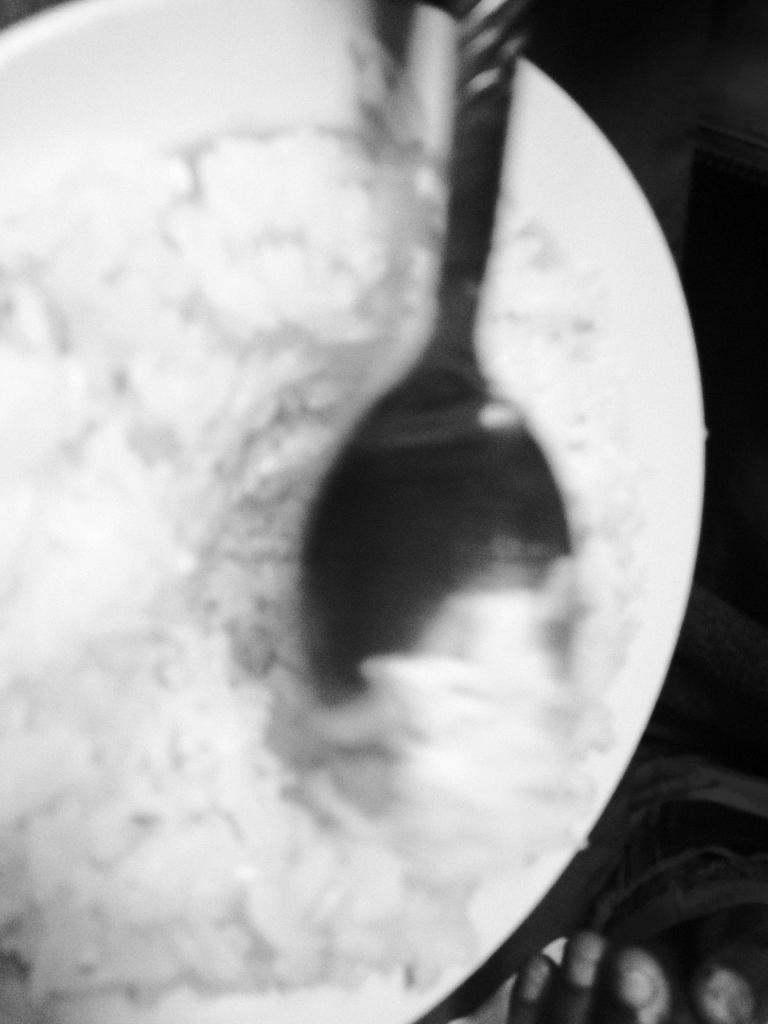What is the overall quality of the image? The image is blurry. What can be seen inside the bowl in the image? There is a spoon inside a bowl in the image. Can you describe any human body parts visible in the image? Four fingers of a person are visible beside the bowl in the image. What type of butter is being spread on the stage in the image? There is no butter or stage present in the image; it features a blurry image of a bowl with a spoon inside and four fingers beside it. 